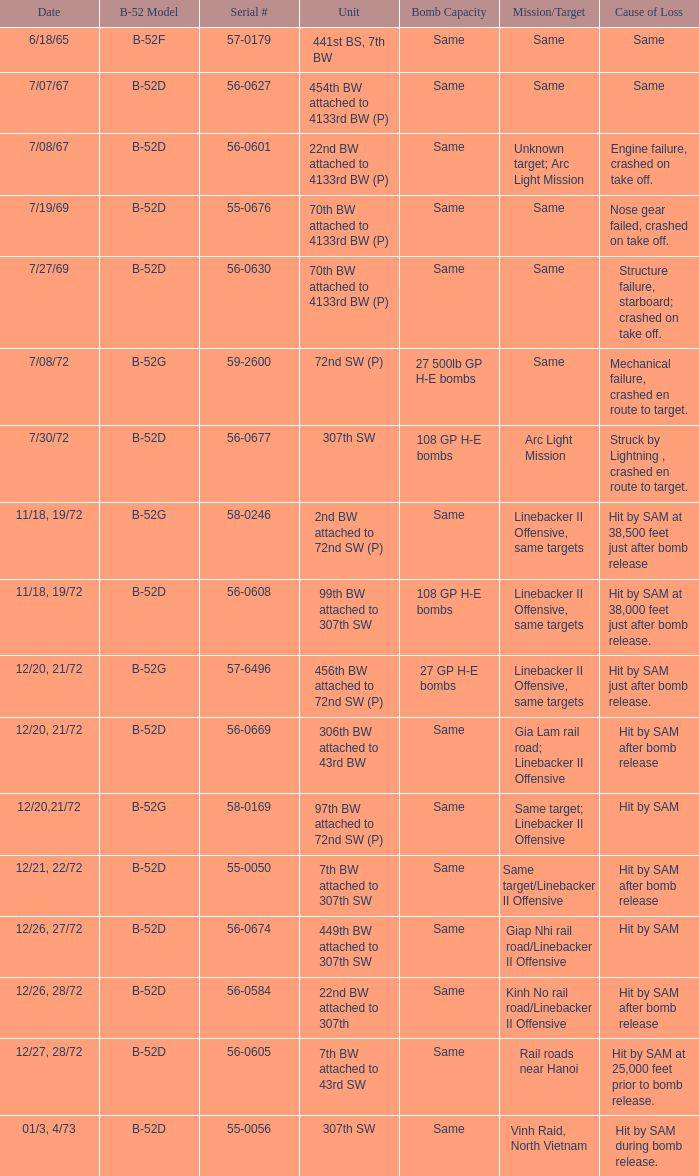What is the specific unit involved when the linebacker ii offensive has the same target? 97th BW attached to 72nd SW (P). 